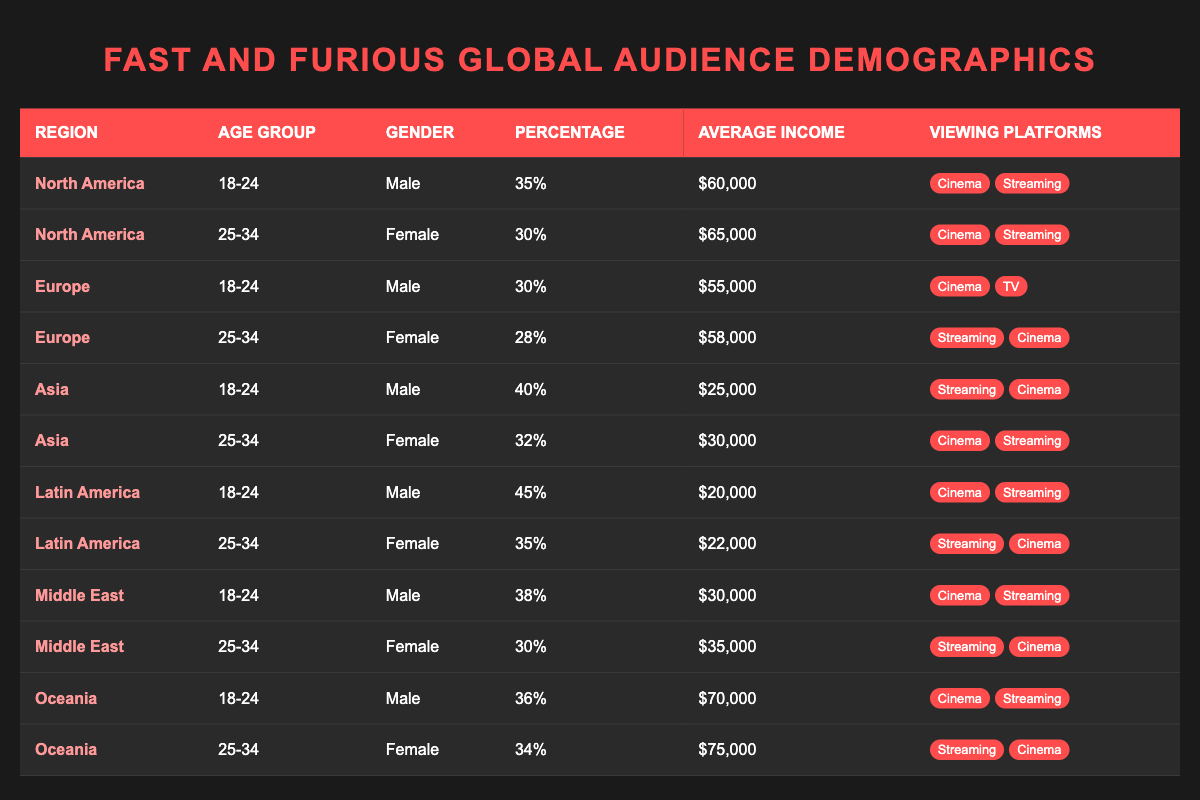What percentage of male viewers in Latin America are aged 18-24? From the table, the row for Latin America under the age group 18-24 and gender male shows a percentage of 45.
Answer: 45 What is the average income of female viewers aged 25-34 in North America? From the table, for North America and the age group 25-34, the average income for female viewers is listed as 65,000.
Answer: 65,000 Is there a viewing platform that is common among all age groups in Asia? Upon reviewing the table, both age groups (18-24 and 25-34) for Asia list "Cinema" and "Streaming" as the viewing platforms, indicating that these platforms are common across age groups.
Answer: Yes What is the combined percentage of male viewers aged 18-24 across all regions? The percentages for male viewers aged 18-24 are: North America (35), Europe (30), Asia (40), Latin America (45), Middle East (38), and Oceania (36). Adding these gives: 35 + 30 + 40 + 45 + 38 + 36 = 224.
Answer: 224 Which region has the highest percentage of female viewers aged 25-34? The table shows that for female viewers aged 25-34, the percentages are: North America (30), Europe (28), Asia (32), Latin America (35), Middle East (30), and Oceania (34). The highest value is 35 from Latin America.
Answer: Latin America How many regions show a percentage of female viewers aged 25-34 that is 30 or higher? The corresponding percentages are: North America (30), Europe (28), Asia (32), Latin America (35), Middle East (30), and Oceania (34). Counting those above 30 gives us: North America, Asia, Latin America, Middle East, and Oceania, totaling 5 regions.
Answer: 5 What is the percentage difference in male viewers aged 18-24 between North America and Oceania? The percentage of male viewers aged 18-24 in North America is 35 and in Oceania is 36. The difference is calculated as 36 - 35 = 1.
Answer: 1 Are there any male viewers aged 25-34 in the Europe region who prefer only streaming as a viewing platform? Looking at the table, the percentage of male viewers aged 25-34 in Europe does not exist, as this demographic is female, and also no male demographic in this age group specifies only streaming.
Answer: No 